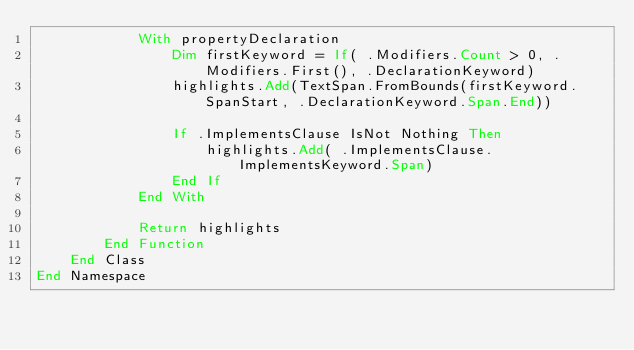Convert code to text. <code><loc_0><loc_0><loc_500><loc_500><_VisualBasic_>            With propertyDeclaration
                Dim firstKeyword = If( .Modifiers.Count > 0, .Modifiers.First(), .DeclarationKeyword)
                highlights.Add(TextSpan.FromBounds(firstKeyword.SpanStart, .DeclarationKeyword.Span.End))

                If .ImplementsClause IsNot Nothing Then
                    highlights.Add( .ImplementsClause.ImplementsKeyword.Span)
                End If
            End With

            Return highlights
        End Function
    End Class
End Namespace
</code> 